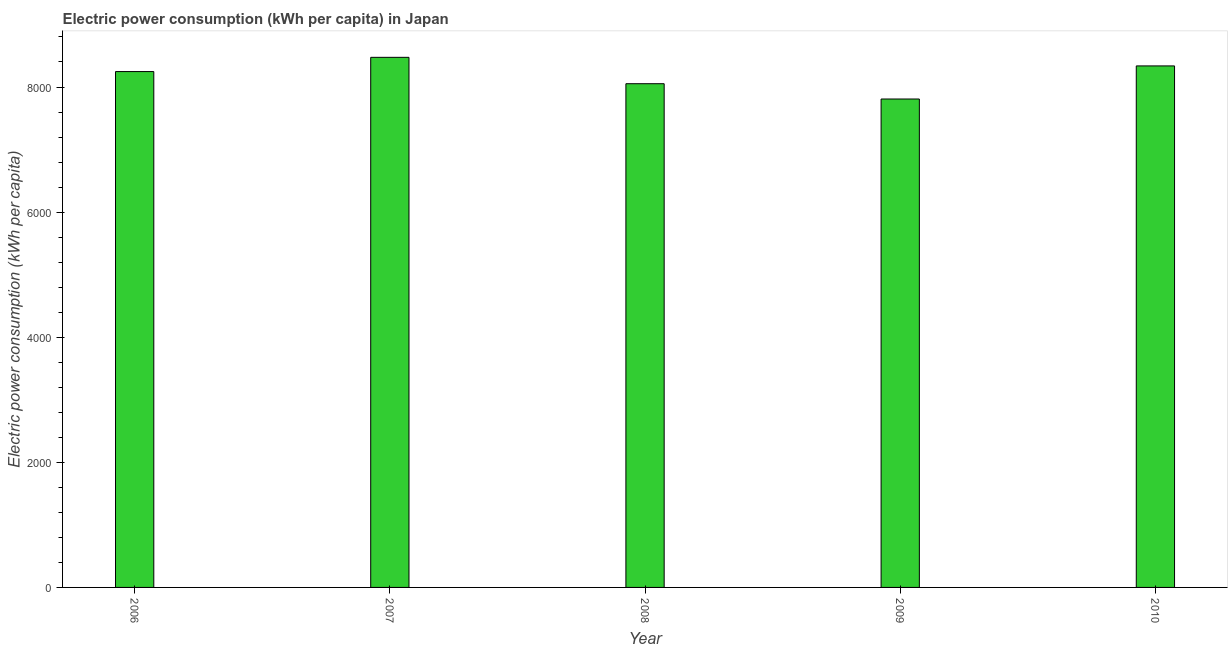Does the graph contain any zero values?
Your response must be concise. No. What is the title of the graph?
Your response must be concise. Electric power consumption (kWh per capita) in Japan. What is the label or title of the X-axis?
Your answer should be very brief. Year. What is the label or title of the Y-axis?
Offer a very short reply. Electric power consumption (kWh per capita). What is the electric power consumption in 2008?
Provide a succinct answer. 8052.58. Across all years, what is the maximum electric power consumption?
Offer a very short reply. 8474.38. Across all years, what is the minimum electric power consumption?
Give a very brief answer. 7808.07. In which year was the electric power consumption minimum?
Your answer should be very brief. 2009. What is the sum of the electric power consumption?
Offer a very short reply. 4.09e+04. What is the difference between the electric power consumption in 2008 and 2009?
Your answer should be compact. 244.5. What is the average electric power consumption per year?
Offer a terse response. 8183.76. What is the median electric power consumption?
Offer a terse response. 8246.63. In how many years, is the electric power consumption greater than 7200 kWh per capita?
Give a very brief answer. 5. Is the electric power consumption in 2007 less than that in 2008?
Keep it short and to the point. No. Is the difference between the electric power consumption in 2007 and 2009 greater than the difference between any two years?
Your answer should be compact. Yes. What is the difference between the highest and the second highest electric power consumption?
Your answer should be compact. 137.25. What is the difference between the highest and the lowest electric power consumption?
Ensure brevity in your answer.  666.31. What is the Electric power consumption (kWh per capita) in 2006?
Give a very brief answer. 8246.63. What is the Electric power consumption (kWh per capita) of 2007?
Provide a succinct answer. 8474.38. What is the Electric power consumption (kWh per capita) in 2008?
Offer a terse response. 8052.58. What is the Electric power consumption (kWh per capita) in 2009?
Give a very brief answer. 7808.07. What is the Electric power consumption (kWh per capita) in 2010?
Ensure brevity in your answer.  8337.13. What is the difference between the Electric power consumption (kWh per capita) in 2006 and 2007?
Keep it short and to the point. -227.75. What is the difference between the Electric power consumption (kWh per capita) in 2006 and 2008?
Your answer should be compact. 194.05. What is the difference between the Electric power consumption (kWh per capita) in 2006 and 2009?
Your response must be concise. 438.55. What is the difference between the Electric power consumption (kWh per capita) in 2006 and 2010?
Offer a terse response. -90.5. What is the difference between the Electric power consumption (kWh per capita) in 2007 and 2008?
Give a very brief answer. 421.8. What is the difference between the Electric power consumption (kWh per capita) in 2007 and 2009?
Provide a short and direct response. 666.31. What is the difference between the Electric power consumption (kWh per capita) in 2007 and 2010?
Your answer should be very brief. 137.25. What is the difference between the Electric power consumption (kWh per capita) in 2008 and 2009?
Your response must be concise. 244.51. What is the difference between the Electric power consumption (kWh per capita) in 2008 and 2010?
Your answer should be very brief. -284.55. What is the difference between the Electric power consumption (kWh per capita) in 2009 and 2010?
Keep it short and to the point. -529.06. What is the ratio of the Electric power consumption (kWh per capita) in 2006 to that in 2007?
Your response must be concise. 0.97. What is the ratio of the Electric power consumption (kWh per capita) in 2006 to that in 2009?
Keep it short and to the point. 1.06. What is the ratio of the Electric power consumption (kWh per capita) in 2007 to that in 2008?
Provide a short and direct response. 1.05. What is the ratio of the Electric power consumption (kWh per capita) in 2007 to that in 2009?
Your answer should be very brief. 1.08. What is the ratio of the Electric power consumption (kWh per capita) in 2008 to that in 2009?
Ensure brevity in your answer.  1.03. What is the ratio of the Electric power consumption (kWh per capita) in 2008 to that in 2010?
Give a very brief answer. 0.97. What is the ratio of the Electric power consumption (kWh per capita) in 2009 to that in 2010?
Offer a very short reply. 0.94. 